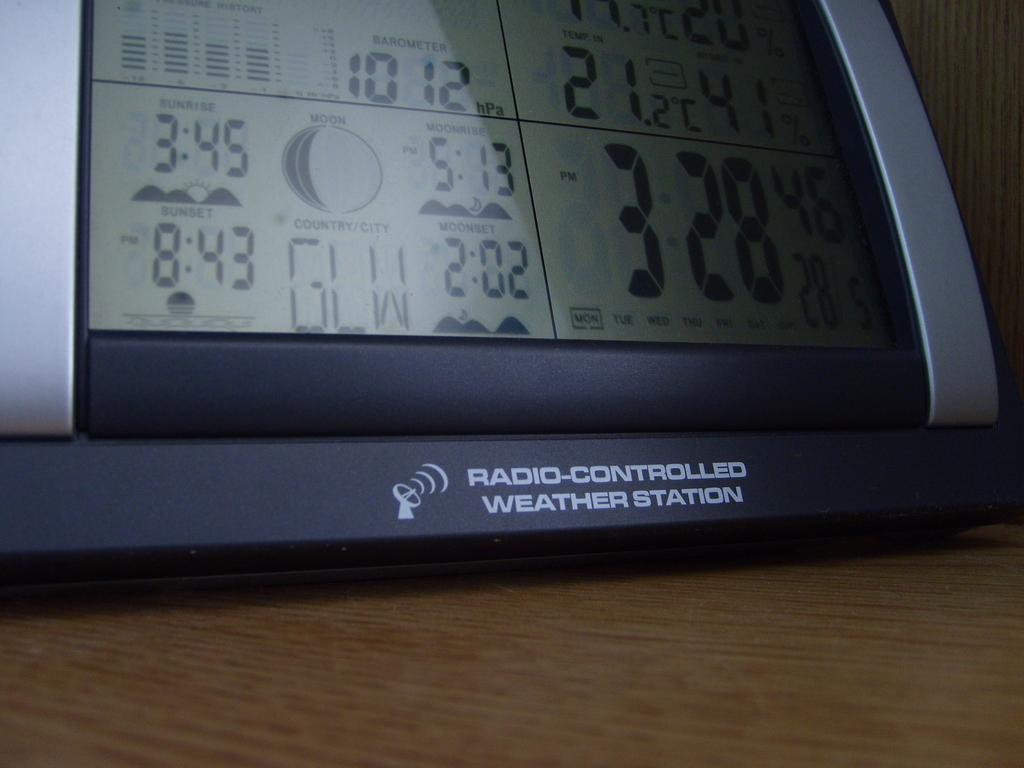Describe this image in one or two sentences. In this picture we can see a device placed on a wooden platform and in the background we can see the wall. 